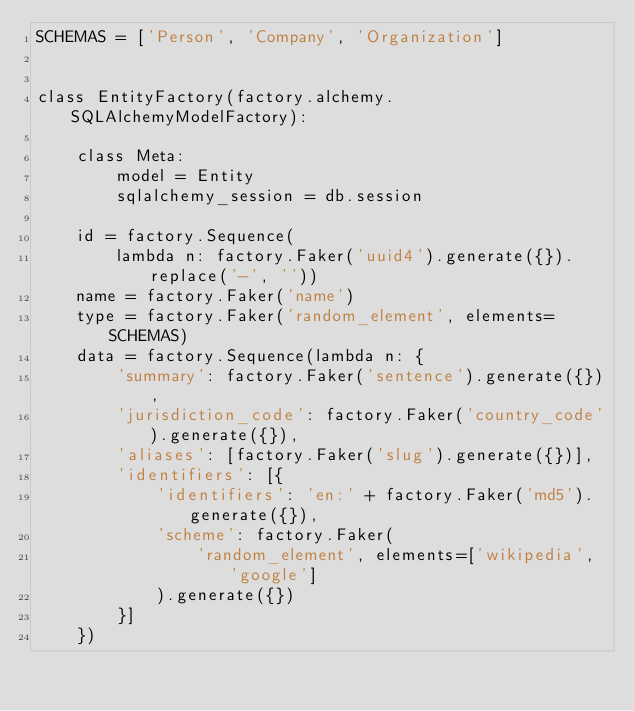<code> <loc_0><loc_0><loc_500><loc_500><_Python_>SCHEMAS = ['Person', 'Company', 'Organization']


class EntityFactory(factory.alchemy.SQLAlchemyModelFactory):

    class Meta:
        model = Entity
        sqlalchemy_session = db.session

    id = factory.Sequence(
        lambda n: factory.Faker('uuid4').generate({}).replace('-', ''))
    name = factory.Faker('name')
    type = factory.Faker('random_element', elements=SCHEMAS)
    data = factory.Sequence(lambda n: {
        'summary': factory.Faker('sentence').generate({}),
        'jurisdiction_code': factory.Faker('country_code').generate({}),
        'aliases': [factory.Faker('slug').generate({})],
        'identifiers': [{
            'identifiers': 'en:' + factory.Faker('md5').generate({}),
            'scheme': factory.Faker(
                'random_element', elements=['wikipedia', 'google']
            ).generate({})
        }]
    })
</code> 